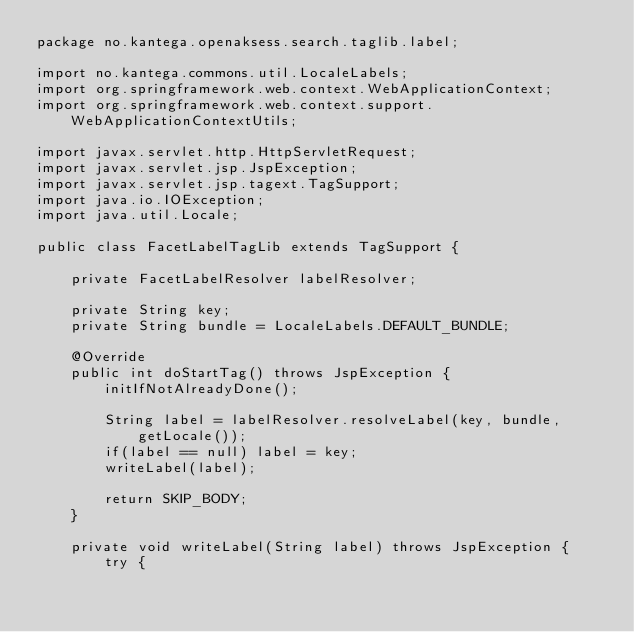Convert code to text. <code><loc_0><loc_0><loc_500><loc_500><_Java_>package no.kantega.openaksess.search.taglib.label;

import no.kantega.commons.util.LocaleLabels;
import org.springframework.web.context.WebApplicationContext;
import org.springframework.web.context.support.WebApplicationContextUtils;

import javax.servlet.http.HttpServletRequest;
import javax.servlet.jsp.JspException;
import javax.servlet.jsp.tagext.TagSupport;
import java.io.IOException;
import java.util.Locale;

public class FacetLabelTagLib extends TagSupport {

    private FacetLabelResolver labelResolver;

    private String key;
    private String bundle = LocaleLabels.DEFAULT_BUNDLE;

    @Override
    public int doStartTag() throws JspException {
        initIfNotAlreadyDone();

        String label = labelResolver.resolveLabel(key, bundle, getLocale());
        if(label == null) label = key;
        writeLabel(label);

        return SKIP_BODY;
    }

    private void writeLabel(String label) throws JspException {
        try {</code> 